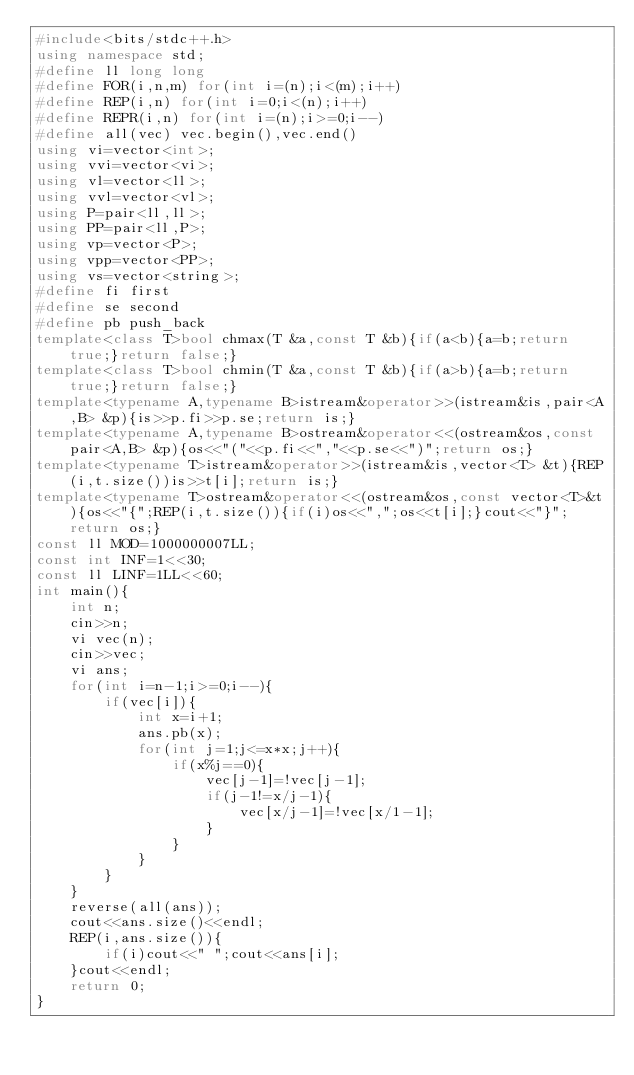<code> <loc_0><loc_0><loc_500><loc_500><_C++_>#include<bits/stdc++.h>
using namespace std;
#define ll long long
#define FOR(i,n,m) for(int i=(n);i<(m);i++)
#define REP(i,n) for(int i=0;i<(n);i++)
#define REPR(i,n) for(int i=(n);i>=0;i--)
#define all(vec) vec.begin(),vec.end()
using vi=vector<int>;
using vvi=vector<vi>;
using vl=vector<ll>;
using vvl=vector<vl>;
using P=pair<ll,ll>;
using PP=pair<ll,P>;
using vp=vector<P>;
using vpp=vector<PP>;
using vs=vector<string>;
#define fi first
#define se second
#define pb push_back
template<class T>bool chmax(T &a,const T &b){if(a<b){a=b;return true;}return false;}
template<class T>bool chmin(T &a,const T &b){if(a>b){a=b;return true;}return false;}
template<typename A,typename B>istream&operator>>(istream&is,pair<A,B> &p){is>>p.fi>>p.se;return is;}
template<typename A,typename B>ostream&operator<<(ostream&os,const pair<A,B> &p){os<<"("<<p.fi<<","<<p.se<<")";return os;}
template<typename T>istream&operator>>(istream&is,vector<T> &t){REP(i,t.size())is>>t[i];return is;}
template<typename T>ostream&operator<<(ostream&os,const vector<T>&t){os<<"{";REP(i,t.size()){if(i)os<<",";os<<t[i];}cout<<"}";return os;}
const ll MOD=1000000007LL;
const int INF=1<<30;
const ll LINF=1LL<<60;
int main(){
    int n;
    cin>>n;
    vi vec(n);
    cin>>vec;
    vi ans;
    for(int i=n-1;i>=0;i--){
        if(vec[i]){
            int x=i+1;
            ans.pb(x);
            for(int j=1;j<=x*x;j++){
                if(x%j==0){
                    vec[j-1]=!vec[j-1];
                    if(j-1!=x/j-1){
                        vec[x/j-1]=!vec[x/1-1];
                    }
                }
            }
        }
    }
    reverse(all(ans));
    cout<<ans.size()<<endl;
    REP(i,ans.size()){
        if(i)cout<<" ";cout<<ans[i];
    }cout<<endl;
    return 0;
}</code> 